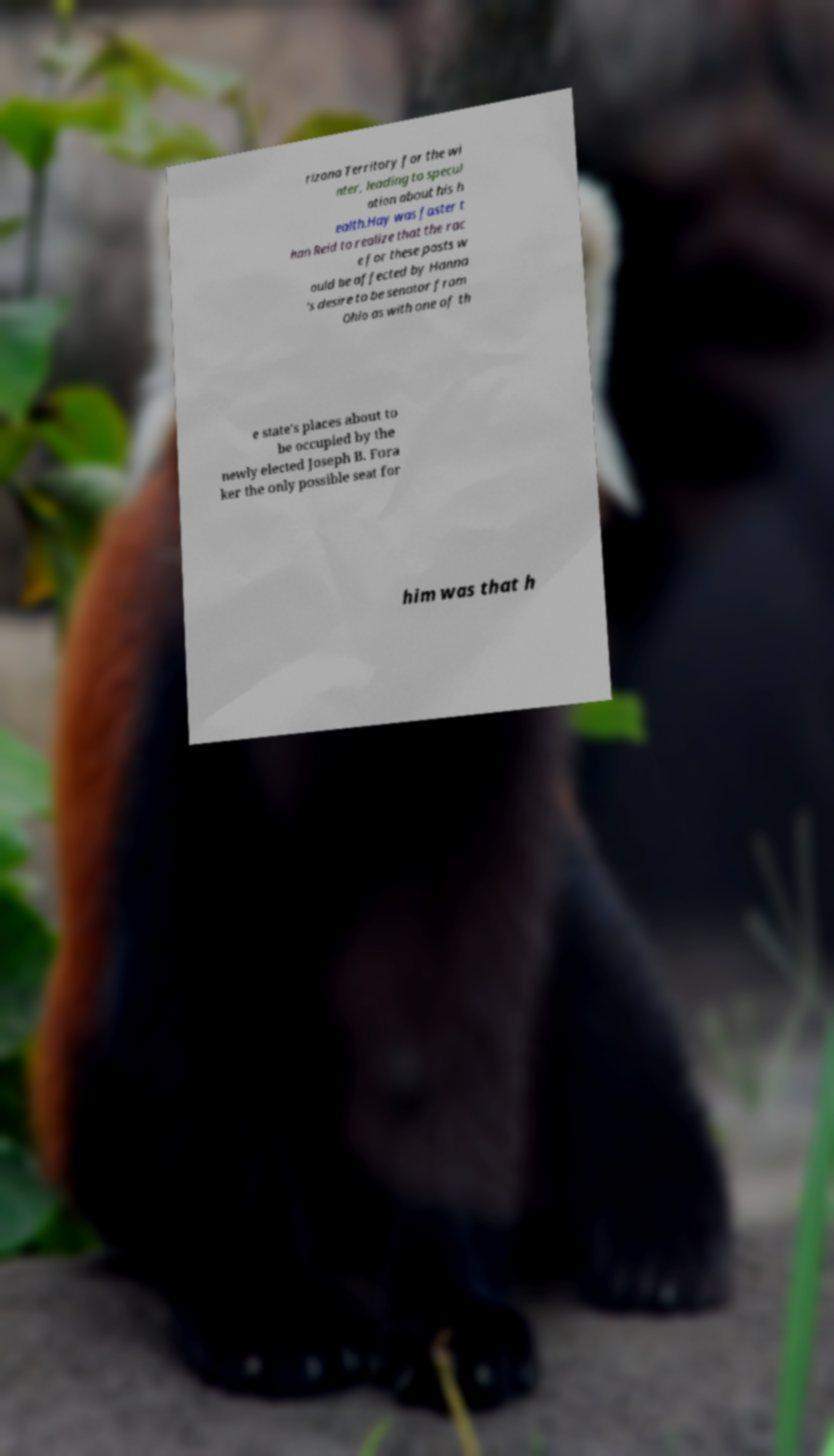Can you accurately transcribe the text from the provided image for me? rizona Territory for the wi nter, leading to specul ation about his h ealth.Hay was faster t han Reid to realize that the rac e for these posts w ould be affected by Hanna 's desire to be senator from Ohio as with one of th e state's places about to be occupied by the newly elected Joseph B. Fora ker the only possible seat for him was that h 